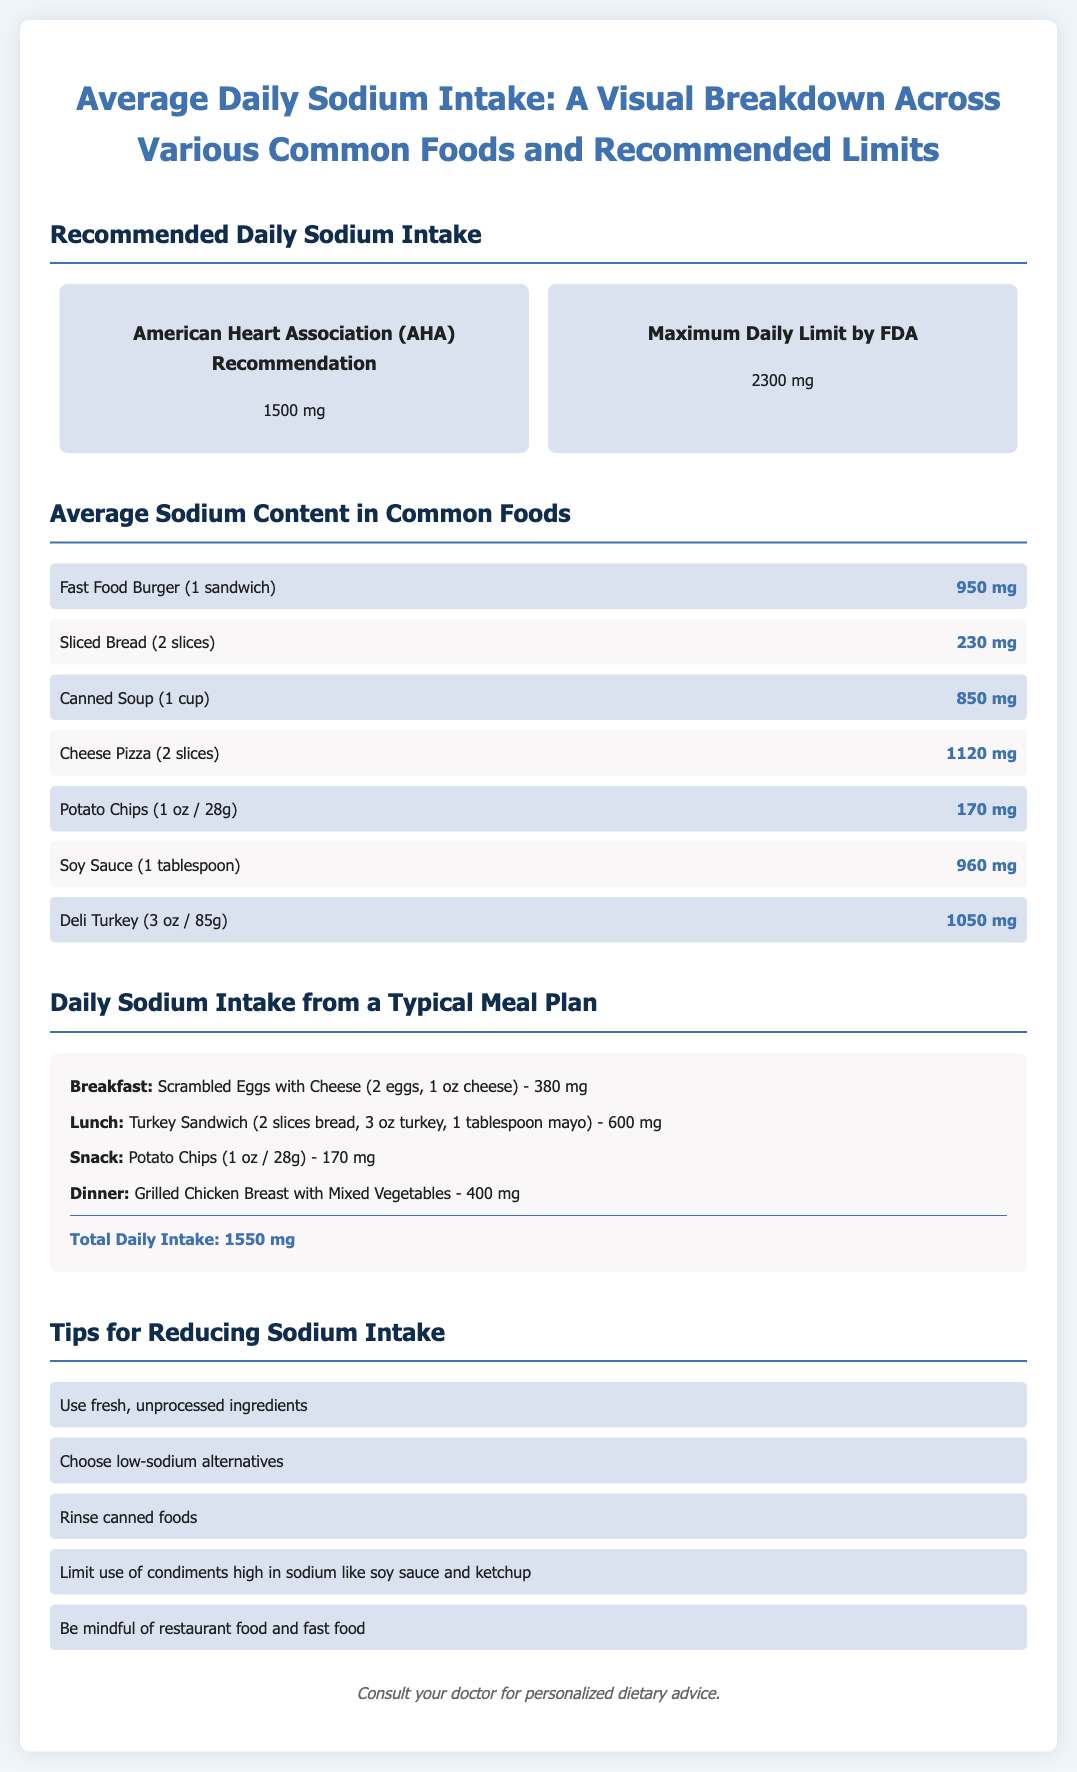what is the American Heart Association's recommended daily sodium intake? The American Heart Association recommends a daily sodium intake of 1500 mg.
Answer: 1500 mg what is the sodium content of a fast food burger? The sodium content of a fast food burger is stated in the document as 950 mg.
Answer: 950 mg what is the total daily sodium intake from the typical meal plan? The document sums up the sodium intake from the meal plan, which totals 1550 mg.
Answer: 1550 mg which food item has the highest sodium content listed? The food item with the highest sodium content listed is Cheese Pizza, which has 1120 mg.
Answer: Cheese Pizza how much sodium does one tablespoon of soy sauce contain? The document specifies that one tablespoon of soy sauce contains 960 mg of sodium.
Answer: 960 mg what is recommended to reduce sodium intake according to the document? The document lists several tips, one of which is to use fresh, unprocessed ingredients to reduce sodium intake.
Answer: Use fresh, unprocessed ingredients how much sodium is in a deli turkey portion of 3 ounces? The sodium content for a deli turkey portion of 3 ounces is 1050 mg.
Answer: 1050 mg what is the maximum daily sodium limit as per FDA recommendations? The document indicates that the maximum daily limit by the FDA is 2300 mg.
Answer: 2300 mg 